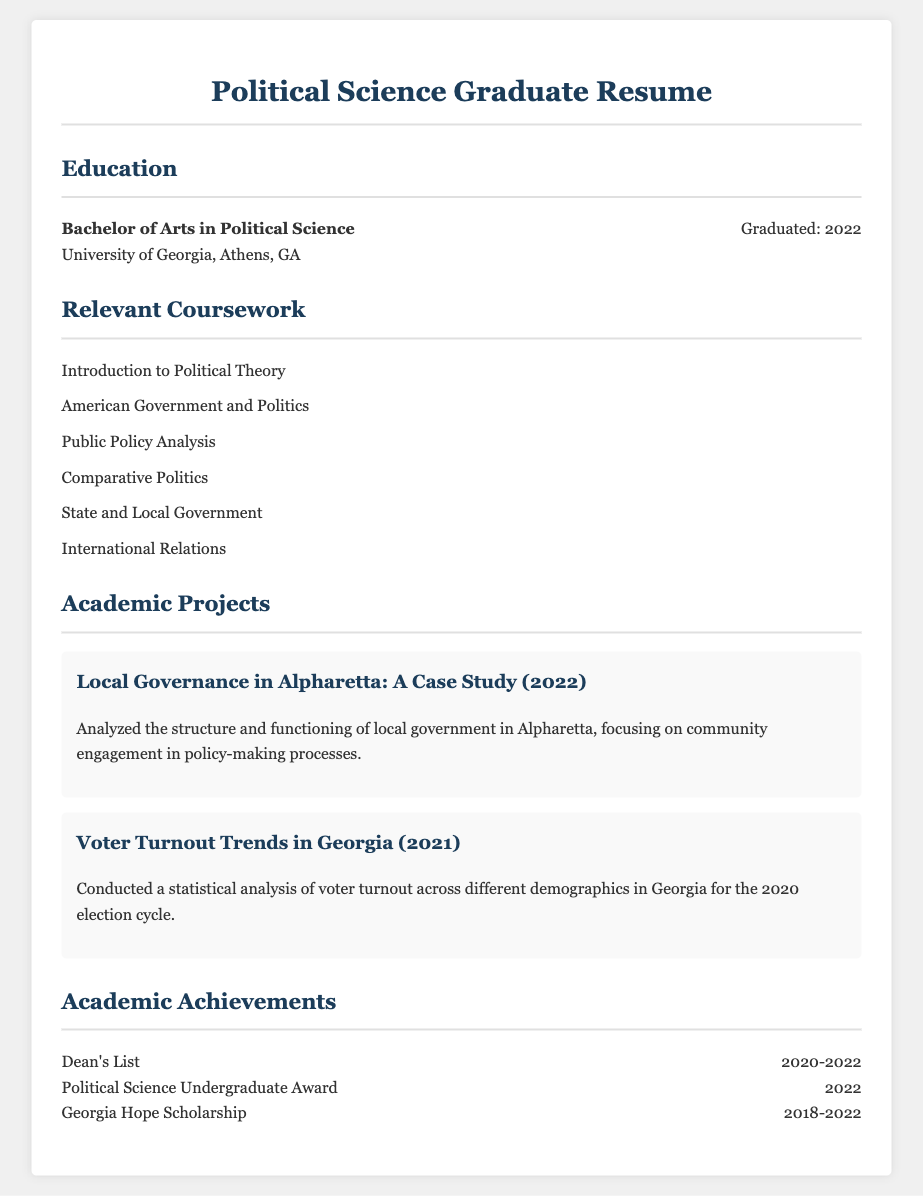What degree was obtained? The document states the degree obtained is a Bachelor of Arts in Political Science.
Answer: Bachelor of Arts in Political Science Where was the degree acquired? The document mentions the University where the degree was obtained, which is the University of Georgia.
Answer: University of Georgia What year did the graduation occur? The document specifies the graduation year as 2022.
Answer: 2022 Name one course included in the relevant coursework. The relevant coursework lists several subjects, one of which is Introduction to Political Theory.
Answer: Introduction to Political Theory What is the title of one academic project? The document provides titles for projects; one is Local Governance in Alpharetta: A Case Study.
Answer: Local Governance in Alpharetta: A Case Study What award was received in 2022? The document lists one award received in 2022 as the Political Science Undergraduate Award.
Answer: Political Science Undergraduate Award For how many years was the Georgia Hope Scholarship awarded? The document mentions the Georgia Hope Scholarship was awarded from 2018 to 2022, which totals four years.
Answer: 4 years What recognition was received for academic performance? The document states that the individual was on the Dean's List for the years 2020-2022.
Answer: Dean's List Which project involved analysis of voter turnout? The document specifies the project titled Voter Turnout Trends in Georgia included voter turnout analysis.
Answer: Voter Turnout Trends in Georgia 